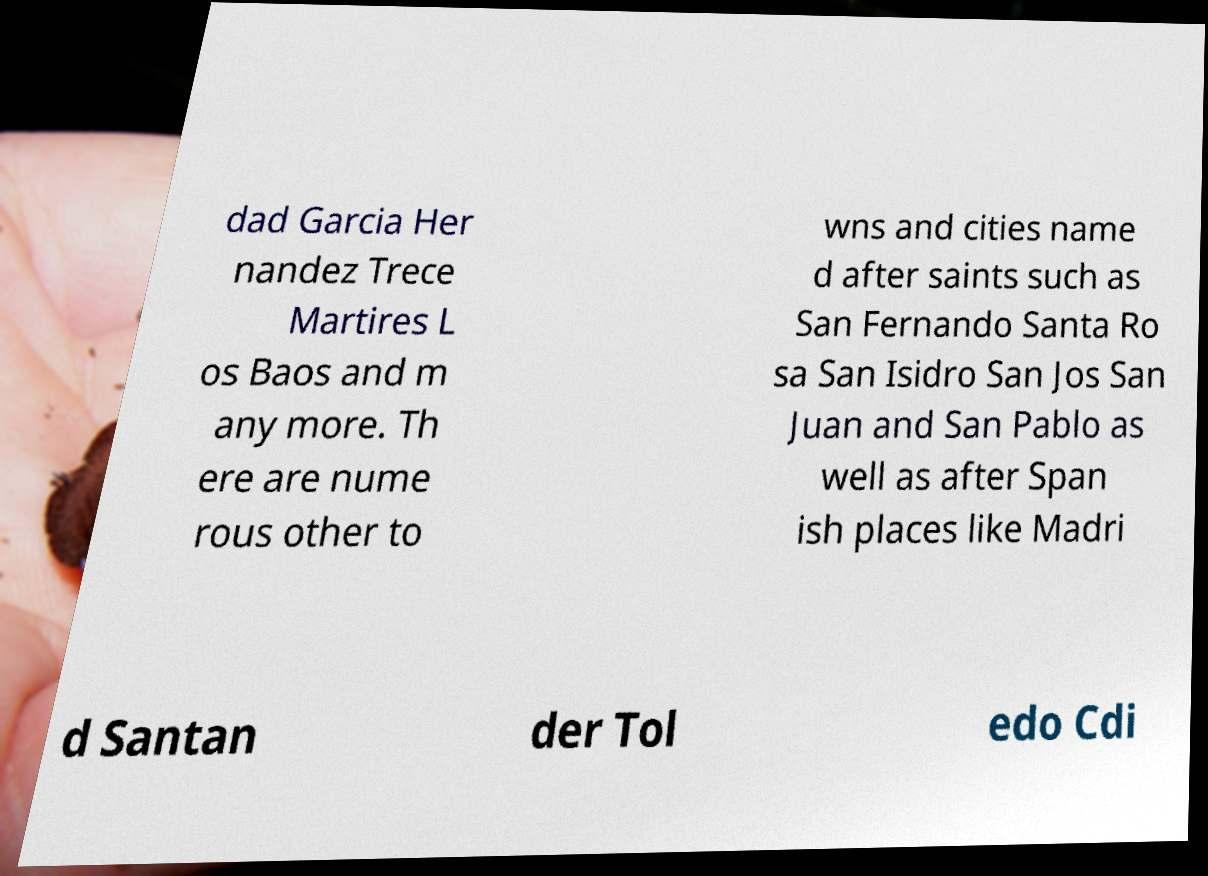Please identify and transcribe the text found in this image. dad Garcia Her nandez Trece Martires L os Baos and m any more. Th ere are nume rous other to wns and cities name d after saints such as San Fernando Santa Ro sa San Isidro San Jos San Juan and San Pablo as well as after Span ish places like Madri d Santan der Tol edo Cdi 